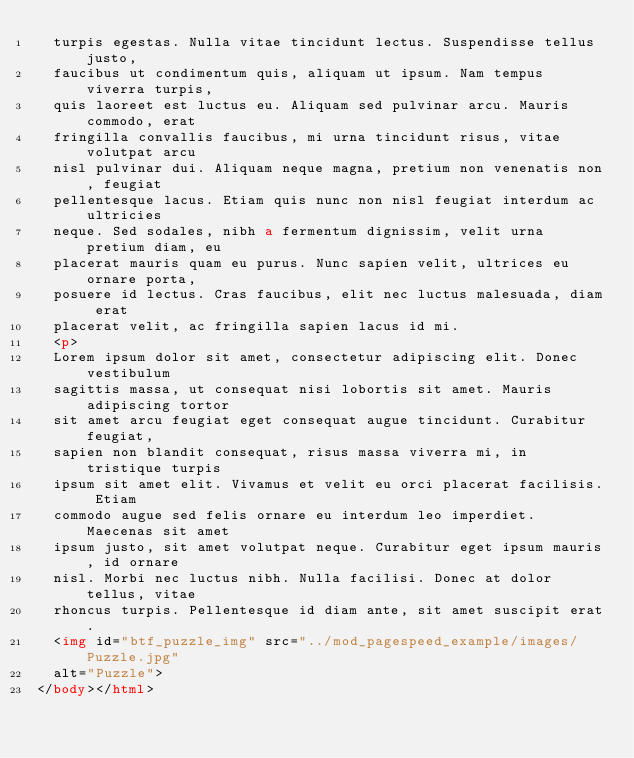<code> <loc_0><loc_0><loc_500><loc_500><_HTML_>  turpis egestas. Nulla vitae tincidunt lectus. Suspendisse tellus justo,
  faucibus ut condimentum quis, aliquam ut ipsum. Nam tempus viverra turpis,
  quis laoreet est luctus eu. Aliquam sed pulvinar arcu. Mauris commodo, erat
  fringilla convallis faucibus, mi urna tincidunt risus, vitae volutpat arcu
  nisl pulvinar dui. Aliquam neque magna, pretium non venenatis non, feugiat
  pellentesque lacus. Etiam quis nunc non nisl feugiat interdum ac ultricies
  neque. Sed sodales, nibh a fermentum dignissim, velit urna pretium diam, eu
  placerat mauris quam eu purus. Nunc sapien velit, ultrices eu ornare porta,
  posuere id lectus. Cras faucibus, elit nec luctus malesuada, diam erat
  placerat velit, ac fringilla sapien lacus id mi.
  <p>
  Lorem ipsum dolor sit amet, consectetur adipiscing elit. Donec vestibulum
  sagittis massa, ut consequat nisi lobortis sit amet. Mauris adipiscing tortor
  sit amet arcu feugiat eget consequat augue tincidunt. Curabitur feugiat,
  sapien non blandit consequat, risus massa viverra mi, in tristique turpis
  ipsum sit amet elit. Vivamus et velit eu orci placerat facilisis. Etiam
  commodo augue sed felis ornare eu interdum leo imperdiet. Maecenas sit amet
  ipsum justo, sit amet volutpat neque. Curabitur eget ipsum mauris, id ornare
  nisl. Morbi nec luctus nibh. Nulla facilisi. Donec at dolor tellus, vitae
  rhoncus turpis. Pellentesque id diam ante, sit amet suscipit erat.
  <img id="btf_puzzle_img" src="../mod_pagespeed_example/images/Puzzle.jpg"
  alt="Puzzle">
</body></html>
</code> 